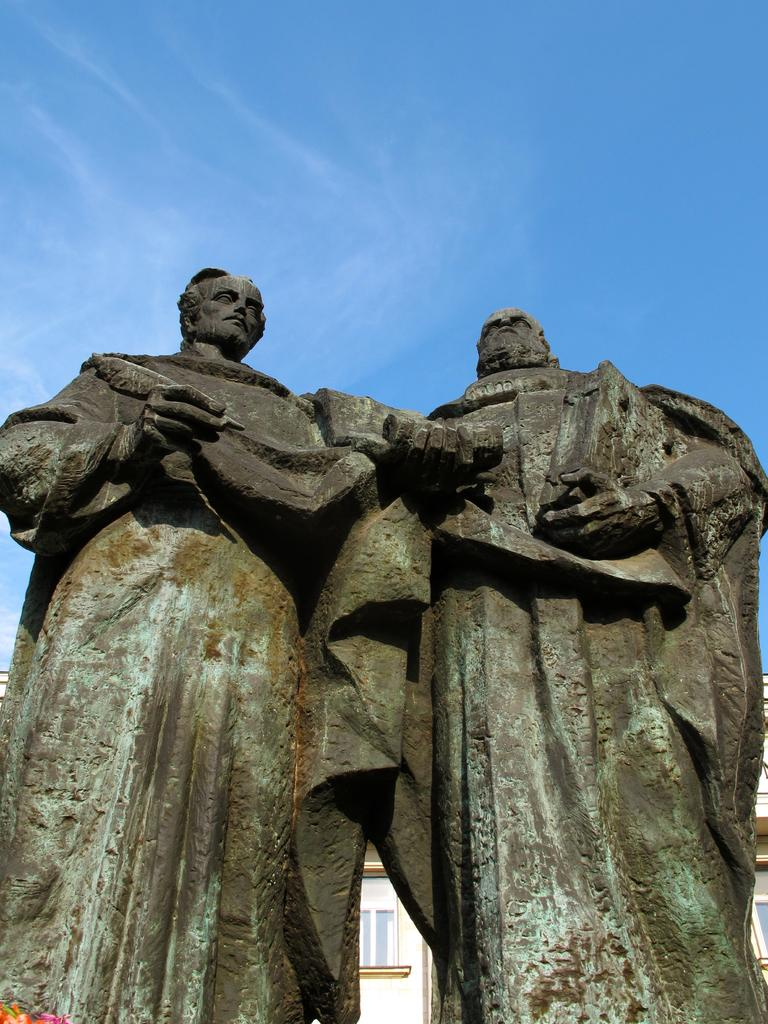What type of objects can be seen in the image? There are statues in the image. What structure is located at the bottom of the image? There is a building at the bottom of the image. What is visible at the top of the image? The sky is visible at the top of the image. What type of dogs are depicted in the caption of the image? There is no caption present in the image, and therefore no dogs can be identified. 